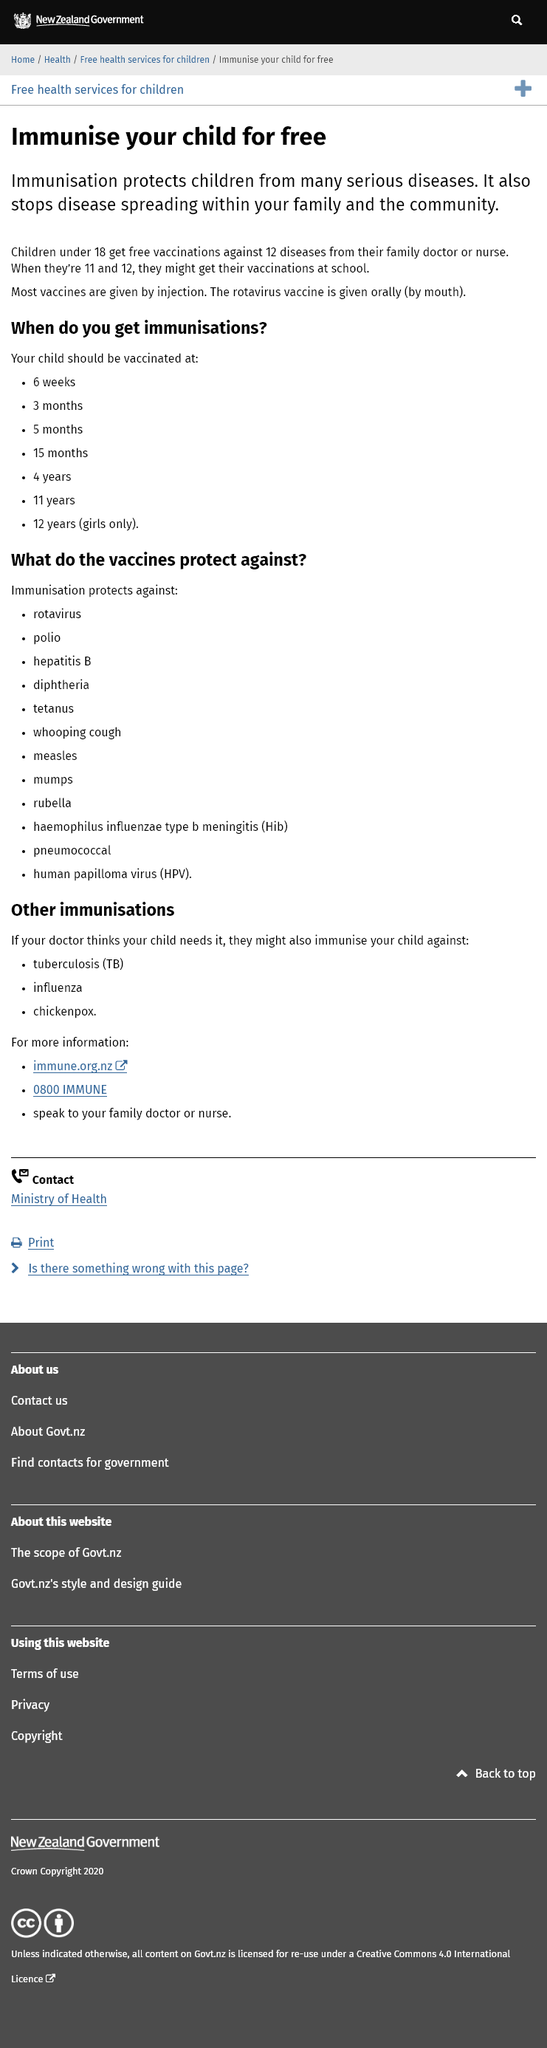Specify some key components in this picture. Vaccines are vital for protecting children from various severe illnesses and preventing the spread of infectious diseases. Vaccines are typically administered through injections, with the exception of the rotavirus vaccine, which is given orally. Vaccines are freely available for children under 18 years of age. 